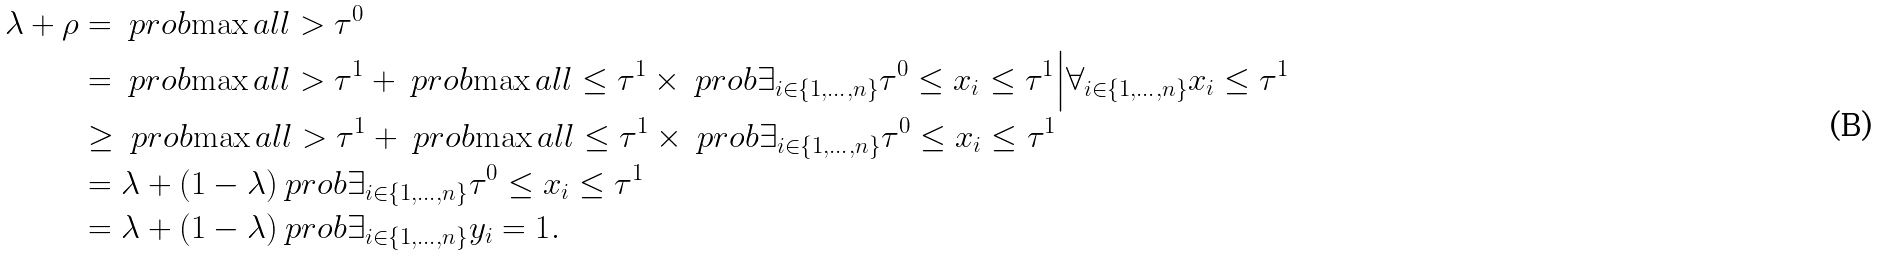Convert formula to latex. <formula><loc_0><loc_0><loc_500><loc_500>\lambda + \rho & = \ p r o b { \max a l l > \tau ^ { 0 } } \\ & = \ p r o b { \max a l l > \tau ^ { 1 } } + \ p r o b { \max a l l \leq \tau ^ { 1 } } \times \ p r o b { \exists _ { i \in \{ 1 , \dots , n \} } \tau ^ { 0 } \leq x _ { i } \leq \tau ^ { 1 } \Big | \forall _ { i \in \{ 1 , \dots , n \} } x _ { i } \leq \tau ^ { 1 } } \\ & \geq \ p r o b { \max a l l > \tau ^ { 1 } } + \ p r o b { \max a l l \leq \tau ^ { 1 } } \times \ p r o b { \exists _ { i \in \{ 1 , \dots , n \} } \tau ^ { 0 } \leq x _ { i } \leq \tau ^ { 1 } } \\ & = \lambda + ( 1 - \lambda ) \ p r o b { \exists _ { i \in \{ 1 , \dots , n \} } \tau ^ { 0 } \leq x _ { i } \leq \tau ^ { 1 } } \\ & = \lambda + ( 1 - \lambda ) \ p r o b { \exists _ { i \in \{ 1 , \dots , n \} } y _ { i } = 1 } .</formula> 